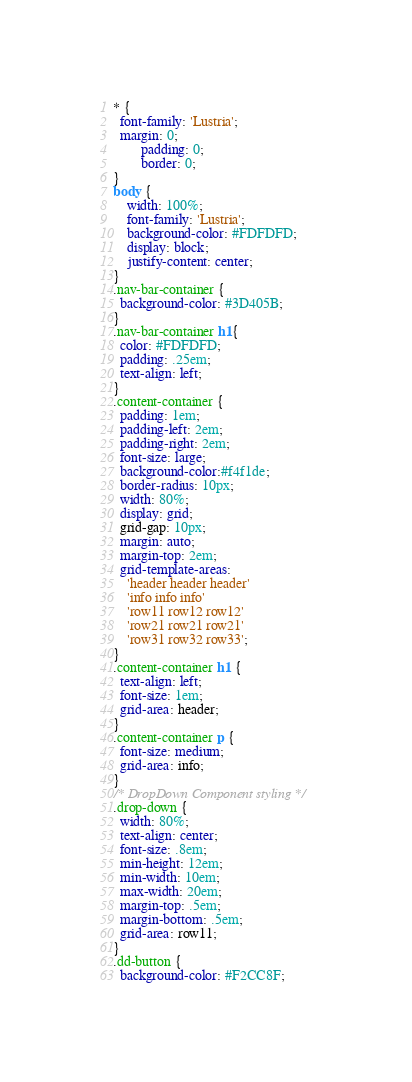Convert code to text. <code><loc_0><loc_0><loc_500><loc_500><_CSS_>* {
  font-family: 'Lustria';
  margin: 0;
        padding: 0;
        border: 0;
}
body {
    width: 100%;
    font-family: 'Lustria';
    background-color: #FDFDFD;
    display: block;
    justify-content: center;
}
.nav-bar-container {
  background-color: #3D405B;
}
.nav-bar-container h1{
  color: #FDFDFD;
  padding: .25em;
  text-align: left;
}
.content-container {
  padding: 1em;
  padding-left: 2em;
  padding-right: 2em;
  font-size: large;
  background-color:#f4f1de;
  border-radius: 10px;
  width: 80%;
  display: grid;
  grid-gap: 10px;
  margin: auto;
  margin-top: 2em;
  grid-template-areas: 
    'header header header'
    'info info info'
    'row11 row12 row12'
    'row21 row21 row21'
    'row31 row32 row33';
}
.content-container h1 {
  text-align: left;
  font-size: 1em;
  grid-area: header;
}
.content-container p {
  font-size: medium;
  grid-area: info;
}
/* DropDown Component styling */
.drop-down {
  width: 80%;
  text-align: center;
  font-size: .8em;
  min-height: 12em;
  min-width: 10em;
  max-width: 20em;
  margin-top: .5em;
  margin-bottom: .5em;
  grid-area: row11;
}
.dd-button {
  background-color: #F2CC8F;</code> 